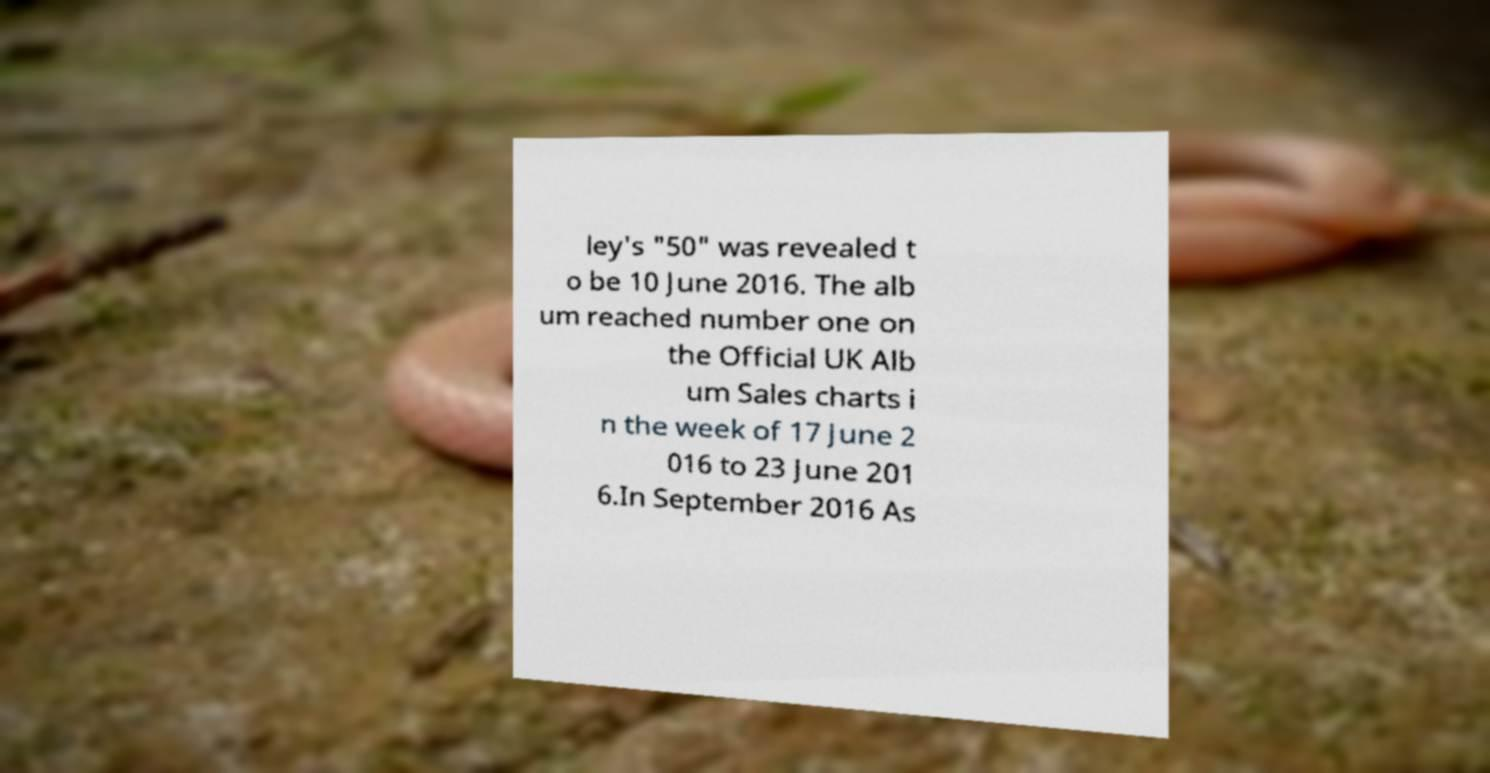For documentation purposes, I need the text within this image transcribed. Could you provide that? ley's "50" was revealed t o be 10 June 2016. The alb um reached number one on the Official UK Alb um Sales charts i n the week of 17 June 2 016 to 23 June 201 6.In September 2016 As 